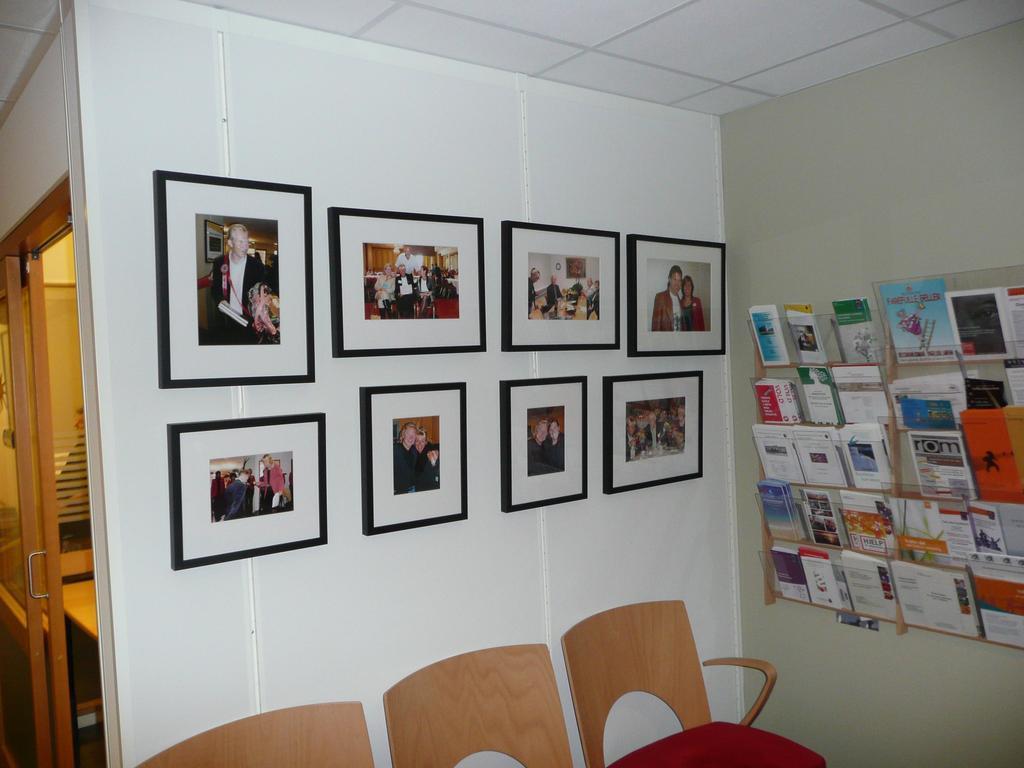Describe this image in one or two sentences. There is wall where we can see some photo frames and on the other wall we can see some books on the wall and below them there are three chairs. 